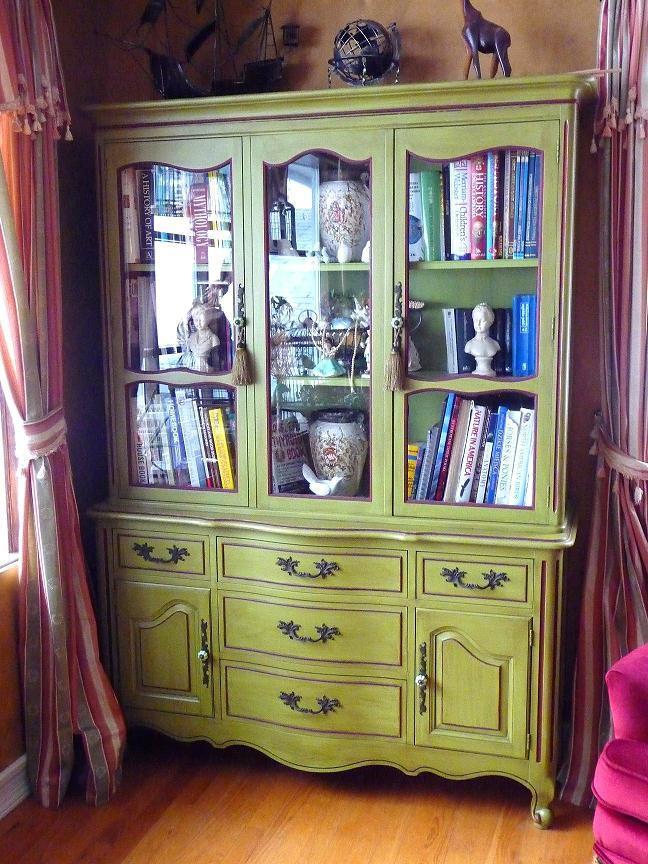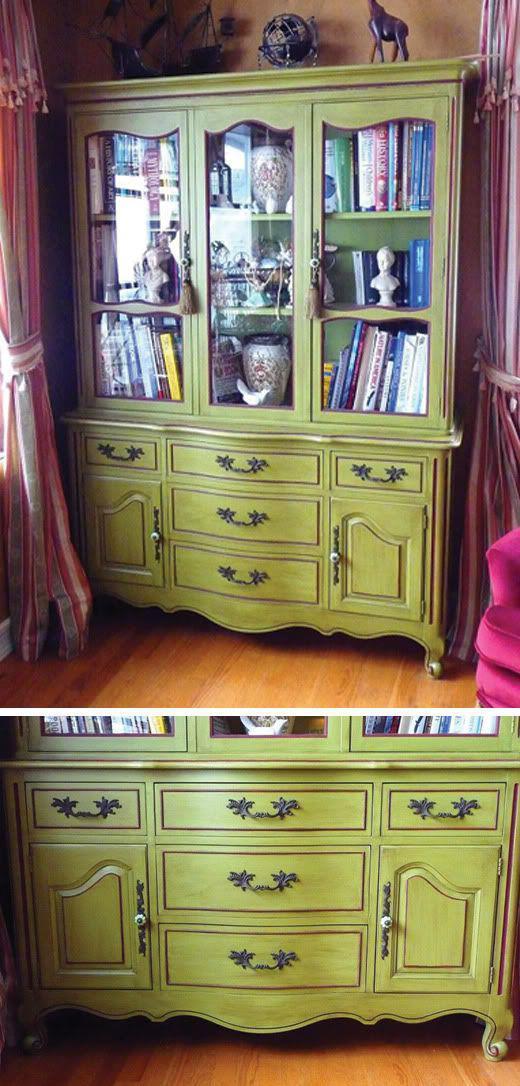The first image is the image on the left, the second image is the image on the right. For the images shown, is this caption "One image features a cabinet with a curved top detail instead of a completely flat top." true? Answer yes or no. No. The first image is the image on the left, the second image is the image on the right. Analyze the images presented: Is the assertion "There are gray diningroom hutches" valid? Answer yes or no. No. 